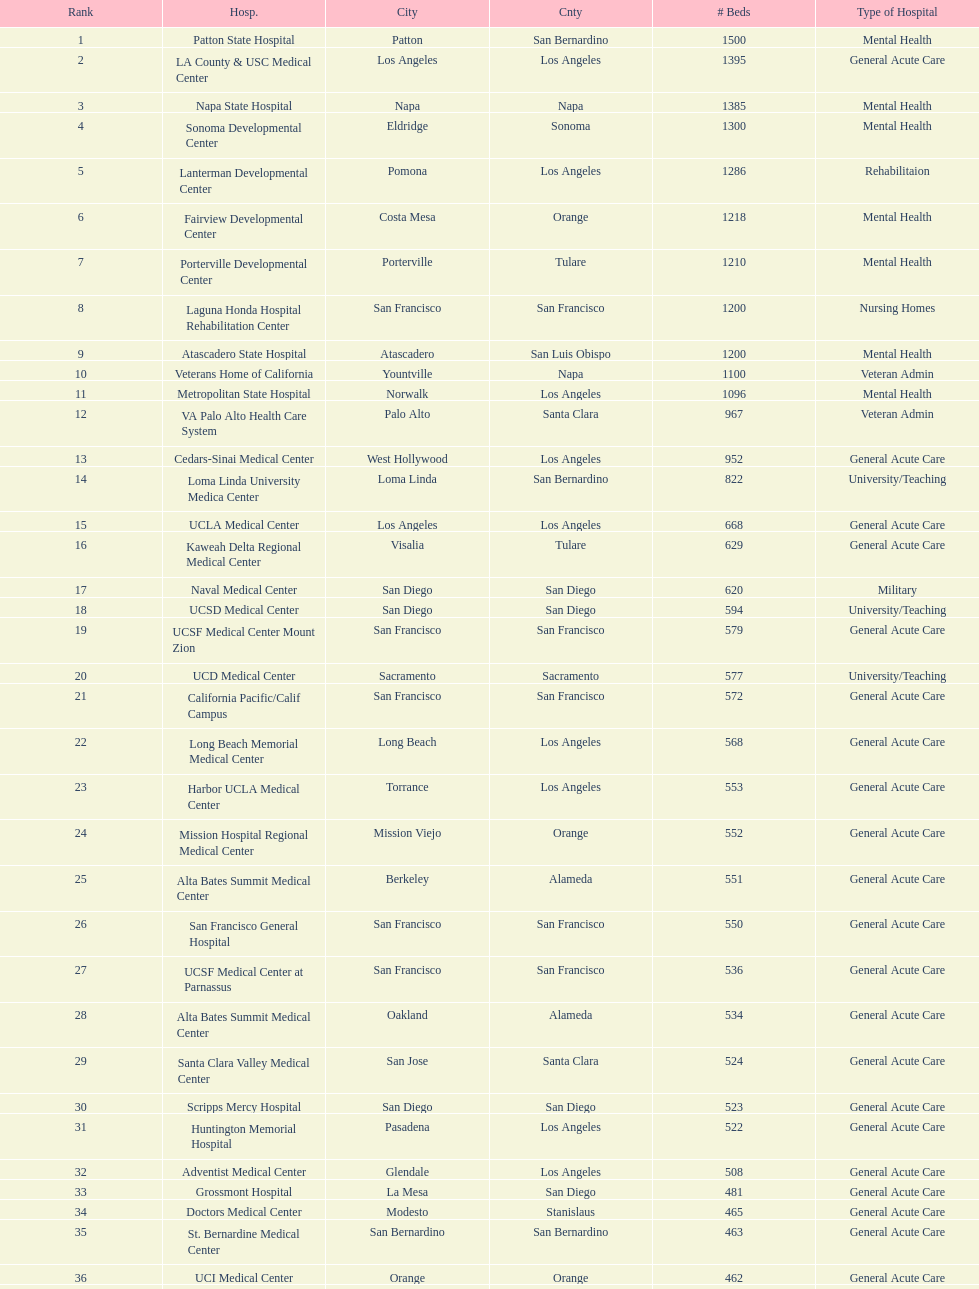Is the number of mental health hospital beds at patton state hospital in san bernardino county greater than those at atascadero state hospital in san luis obispo county? Yes. 